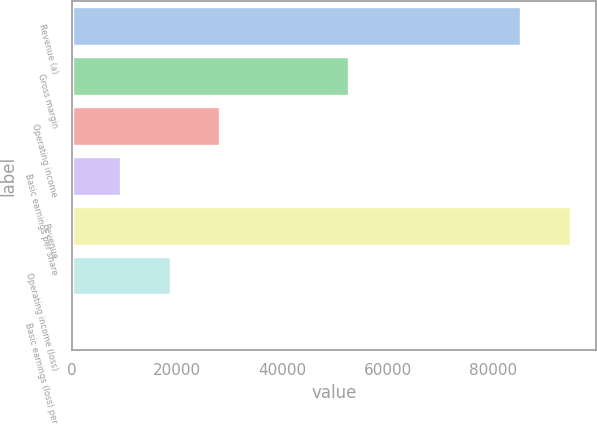Convert chart. <chart><loc_0><loc_0><loc_500><loc_500><bar_chart><fcel>Revenue (a)<fcel>Gross margin<fcel>Operating income<fcel>Basic earnings per share<fcel>Revenue<fcel>Operating income (loss)<fcel>Basic earnings (loss) per<nl><fcel>85320<fcel>52540<fcel>28075<fcel>9359.34<fcel>94677.9<fcel>18717.2<fcel>1.49<nl></chart> 